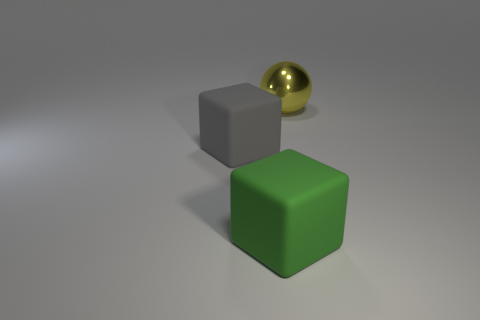Add 3 spheres. How many objects exist? 6 Subtract all blocks. How many objects are left? 1 Subtract all purple rubber balls. Subtract all large yellow things. How many objects are left? 2 Add 2 large green matte cubes. How many large green matte cubes are left? 3 Add 2 green rubber things. How many green rubber things exist? 3 Subtract 0 purple cylinders. How many objects are left? 3 